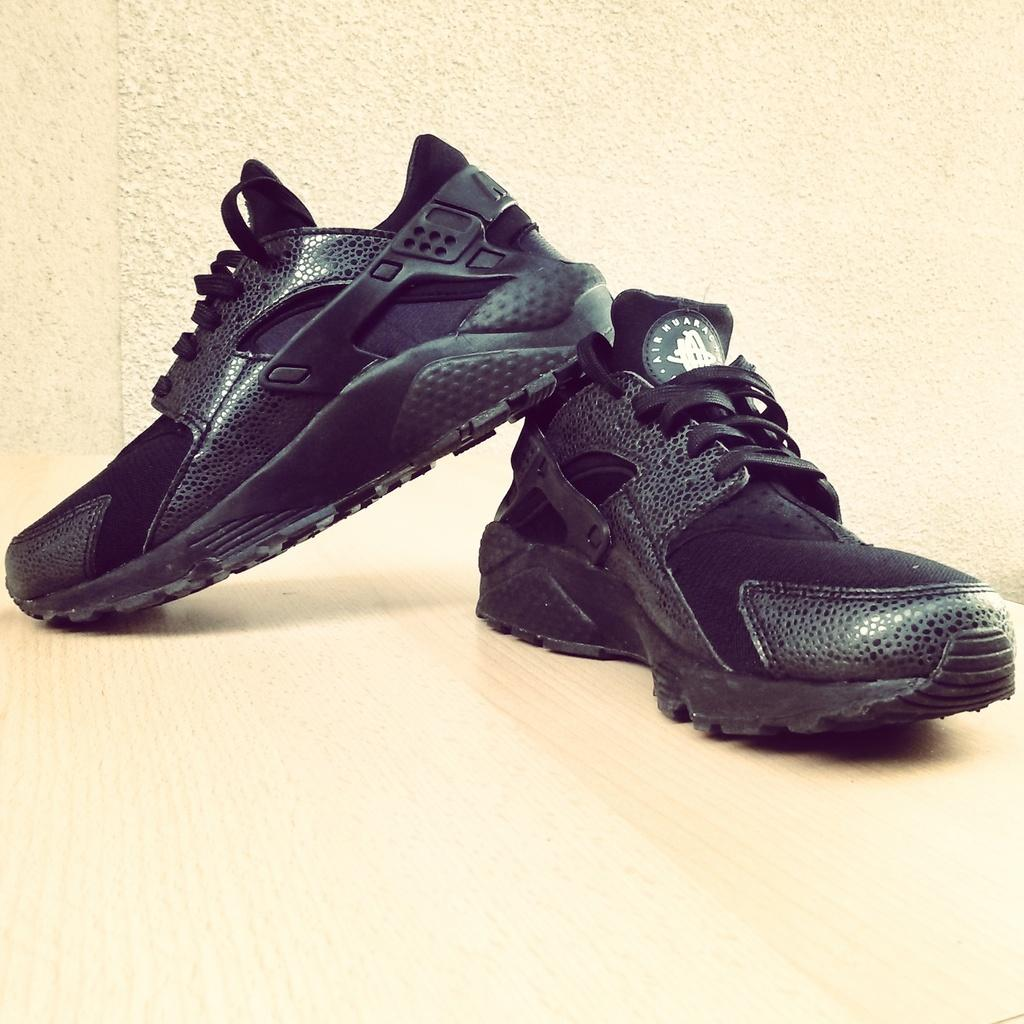What objects are on the ground in the image? There are shoes on the ground. What is visible in the background of the image? There is a wall in the background of the image. What type of appliance is running on the wall in the image? There is no appliance present in the image, and the wall is not running. 